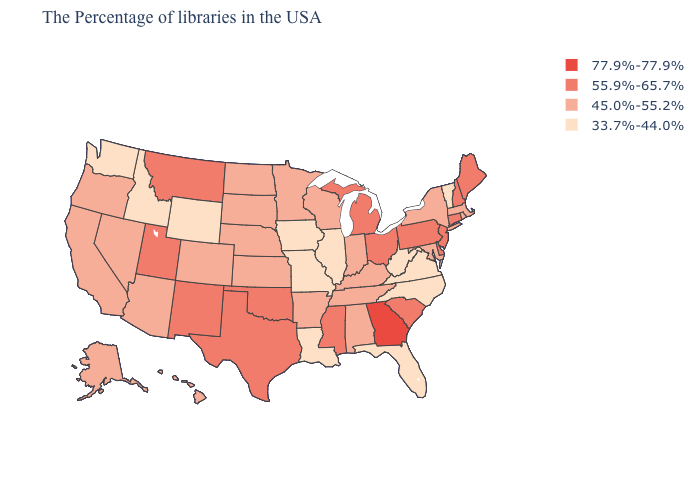Does the first symbol in the legend represent the smallest category?
Be succinct. No. Does the first symbol in the legend represent the smallest category?
Answer briefly. No. What is the value of Virginia?
Be succinct. 33.7%-44.0%. Does Texas have the same value as South Carolina?
Give a very brief answer. Yes. What is the value of Pennsylvania?
Concise answer only. 55.9%-65.7%. Which states hav the highest value in the West?
Write a very short answer. New Mexico, Utah, Montana. Among the states that border Indiana , which have the highest value?
Short answer required. Ohio, Michigan. Does Texas have a lower value than Georgia?
Short answer required. Yes. What is the value of Montana?
Short answer required. 55.9%-65.7%. Name the states that have a value in the range 33.7%-44.0%?
Write a very short answer. Vermont, Virginia, North Carolina, West Virginia, Florida, Illinois, Louisiana, Missouri, Iowa, Wyoming, Idaho, Washington. Does the map have missing data?
Concise answer only. No. Among the states that border Maryland , does West Virginia have the lowest value?
Concise answer only. Yes. Does Rhode Island have the highest value in the Northeast?
Answer briefly. No. What is the value of California?
Quick response, please. 45.0%-55.2%. Does Vermont have the lowest value in the USA?
Concise answer only. Yes. 